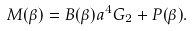<formula> <loc_0><loc_0><loc_500><loc_500>M ( \beta ) = B ( \beta ) a ^ { 4 } G _ { 2 } + P ( \beta ) .</formula> 